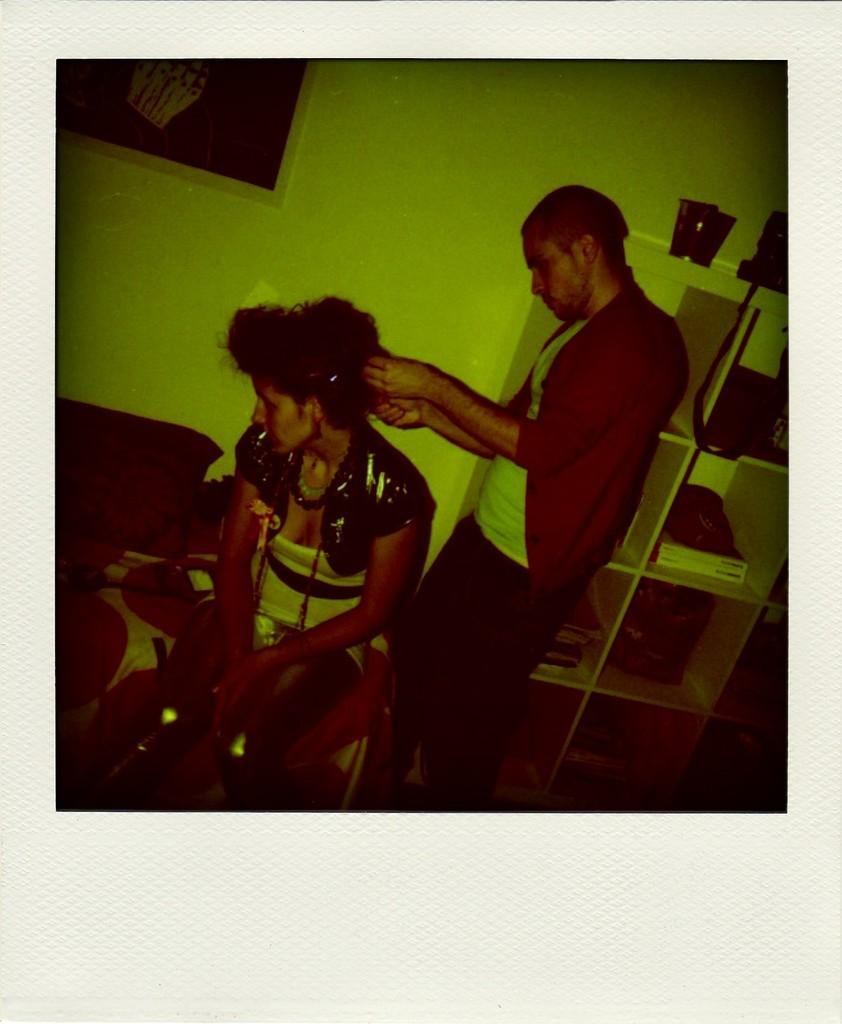What is the position of the man in the image? There is a man standing in the image. What is the position of the woman in the image? There is a woman seated in the image. What is the man doing with his hands in the image? The man is holding the hair of the woman with his hands. What type of furniture can be seen in the image? There are cupboards on the side in the image. What is hanging on the wall in the image? There is a frame on the wall in the image. Reasoning: Let' Let's think step by step in order to produce the conversation. We start by identifying the positions and actions of the man and woman in the image. Then, we describe the furniture and other objects present in the image, such as the cupboards and frame. Each question is designed to elicit a specific detail about the image that is known from the provided facts. Absurd Question/Answer: How many children are playing in the harbor in the image? There is no harbor or children present in the image. What type of cannon is visible in the image? There is no cannon present in the image. How many children are playing in the harbor in the image? There is no harbor or children present in the image. What type of cannon is visible in the image? There is no cannon present in the image. 